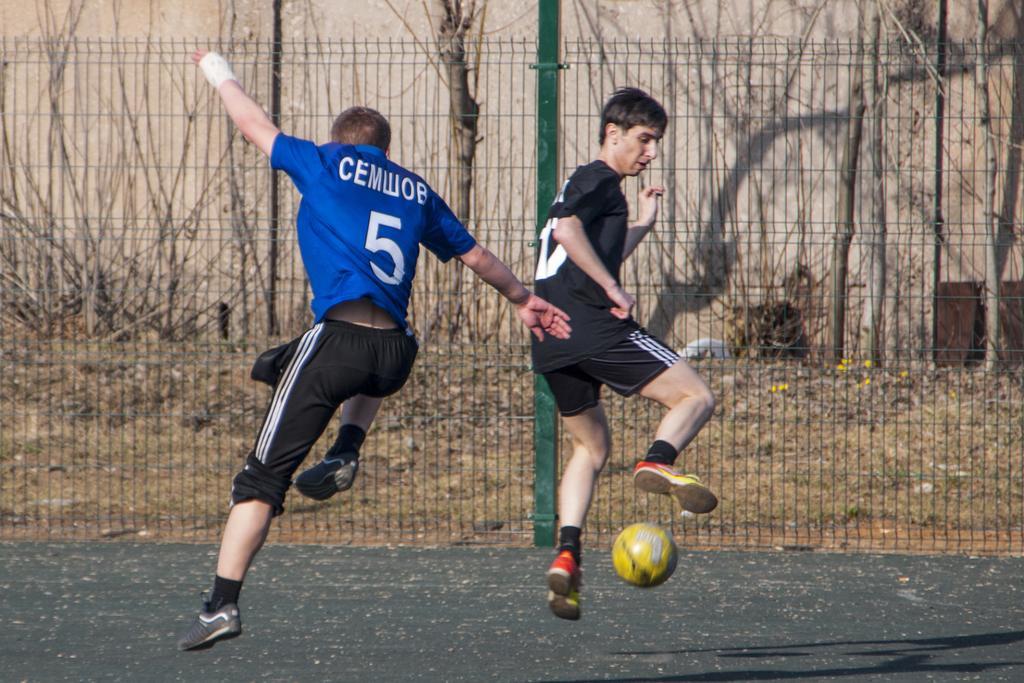Can you describe this image briefly? The pictures taken in a futsal court. In the foreground of the picture there are two persons playing football. In the center of the picture there is fencing, outside the fencing there are trees, stones and soil. At the top there is a wall. 